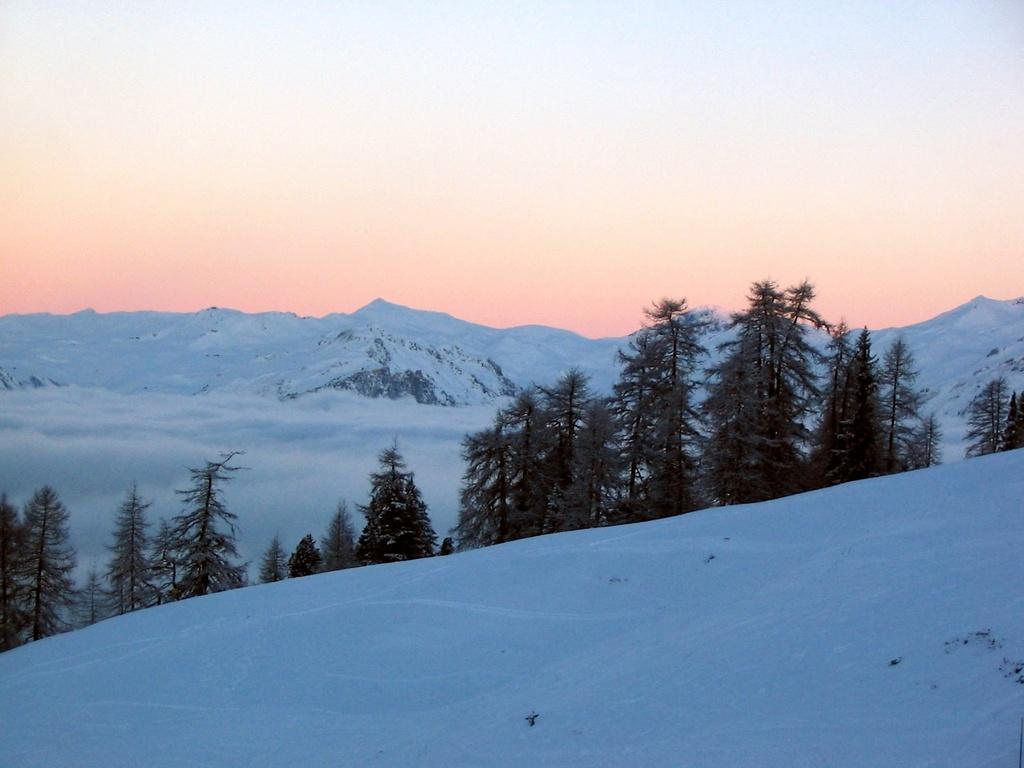What type of vegetation can be seen in the image? There are trees in the image. What is covering the ground in the image? There is snow visible in the image. What can be seen in the distance in the image? There are mountains in the background of the image. What is visible above the mountains in the image? The sky is visible in the background of the image. What type of metal is visible in the image? There is no metal present in the image. What date is shown on the calendar in the image? There is no calendar present in the image. 